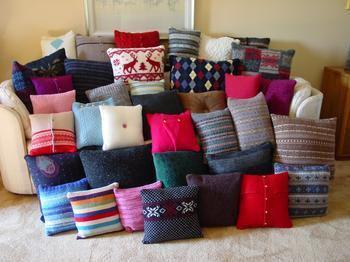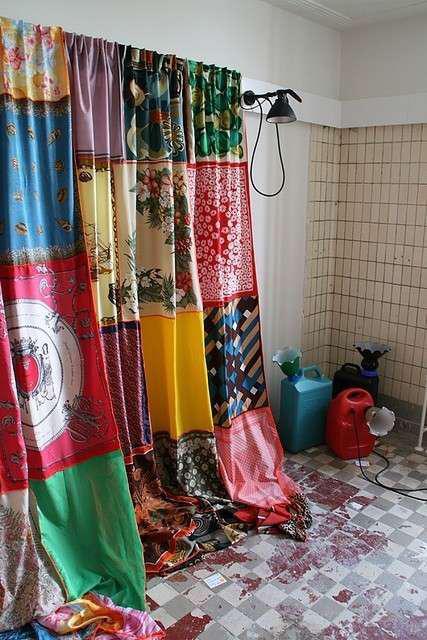The first image is the image on the left, the second image is the image on the right. For the images shown, is this caption "The sofa in the image on the left is buried in pillows" true? Answer yes or no. Yes. 